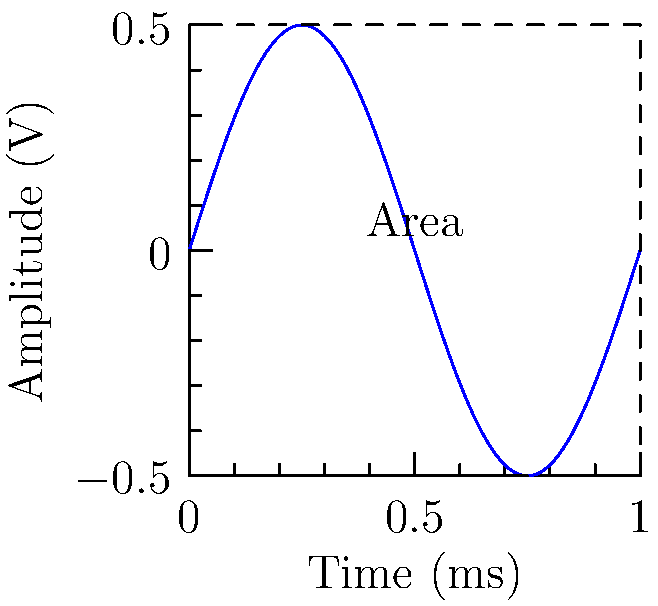An oscilloscope displays a sine wave with a peak-to-peak amplitude of 1 volt and a period of 1 millisecond. Calculate the area enclosed by one complete cycle of the waveform and the time axis, given that the waveform can be approximated by the function $f(t) = 0.5 \sin(2\pi t)$, where $t$ is in milliseconds. To calculate the area enclosed by one complete cycle of the waveform and the time axis, we need to integrate the absolute value of the function over one period. Here's how we do it:

1) The function is $f(t) = 0.5 \sin(2\pi t)$ where $t$ is in milliseconds.

2) One complete cycle occurs over the interval $[0, 1]$ ms.

3) We need to calculate:

   $$A = \int_0^1 |0.5 \sin(2\pi t)| dt$$

4) This integral can't be solved directly due to the absolute value. However, we can split it into two parts:

   $$A = \int_0^{0.5} 0.5 \sin(2\pi t) dt + \int_{0.5}^1 -0.5 \sin(2\pi t) dt$$

5) Solving these integrals:

   $$A = [-\frac{0.5}{2\pi} \cos(2\pi t)]_0^{0.5} + [\frac{0.5}{2\pi} \cos(2\pi t)]_{0.5}^1$$

6) Evaluating:

   $$A = [-\frac{0.5}{2\pi} (-1 - 1)] + [\frac{0.5}{2\pi} (1 - (-1))]$$

   $$A = \frac{1}{2\pi} + \frac{1}{2\pi} = \frac{1}{\pi}$$

7) Therefore, the area enclosed by one complete cycle of the waveform and the time axis is $\frac{1}{\pi}$ volt-milliseconds.
Answer: $\frac{1}{\pi}$ V⋅ms 